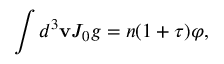<formula> <loc_0><loc_0><loc_500><loc_500>\int d ^ { 3 } { v } J _ { 0 } g = n ( 1 + \tau ) \varphi ,</formula> 